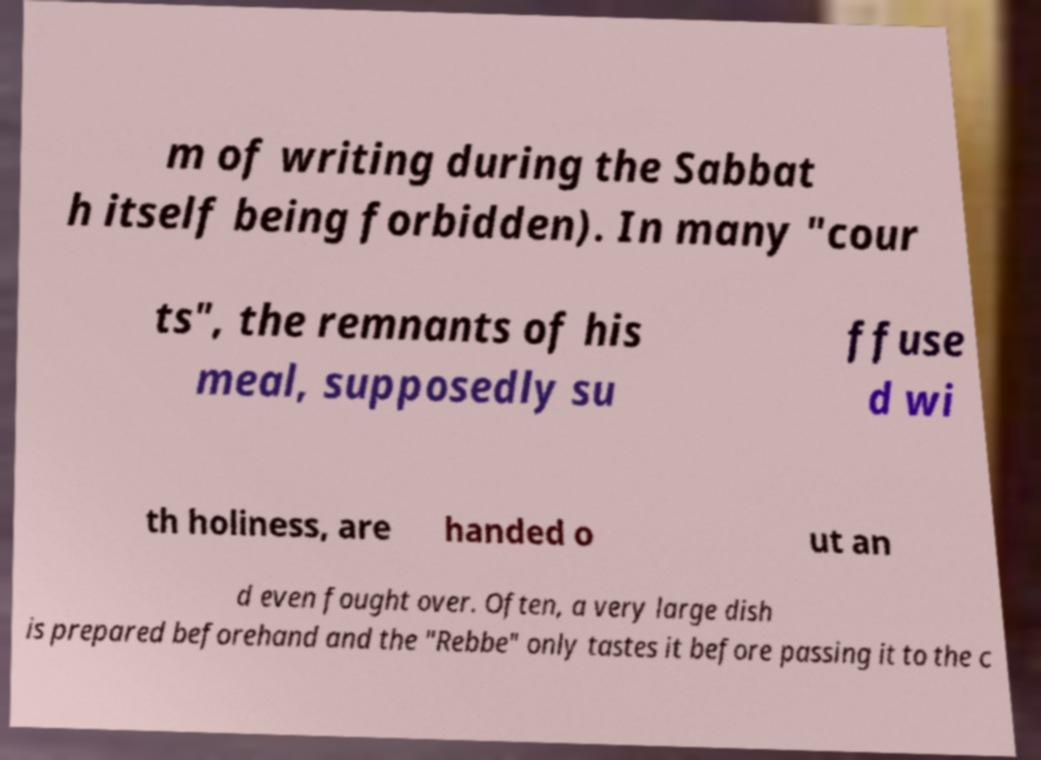Please identify and transcribe the text found in this image. m of writing during the Sabbat h itself being forbidden). In many "cour ts", the remnants of his meal, supposedly su ffuse d wi th holiness, are handed o ut an d even fought over. Often, a very large dish is prepared beforehand and the "Rebbe" only tastes it before passing it to the c 